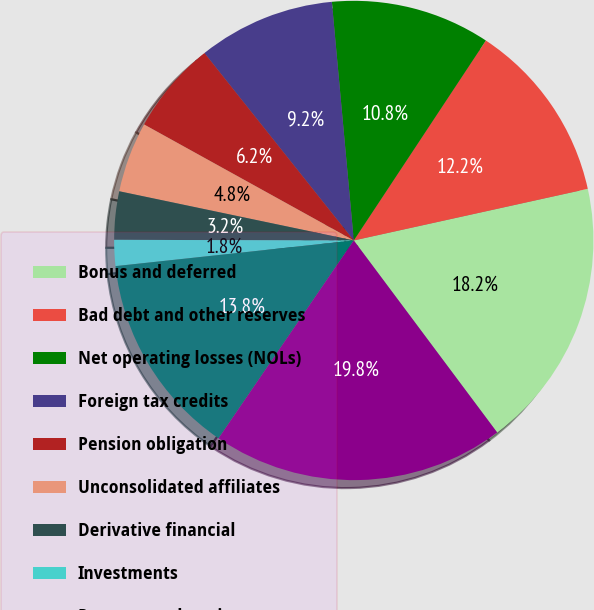Convert chart. <chart><loc_0><loc_0><loc_500><loc_500><pie_chart><fcel>Bonus and deferred<fcel>Bad debt and other reserves<fcel>Net operating losses (NOLs)<fcel>Foreign tax credits<fcel>Pension obligation<fcel>Unconsolidated affiliates<fcel>Derivative financial<fcel>Investments<fcel>Property and equipment<fcel>Capitalized costs and<nl><fcel>18.25%<fcel>12.25%<fcel>10.75%<fcel>9.25%<fcel>6.25%<fcel>4.75%<fcel>3.25%<fcel>1.75%<fcel>13.75%<fcel>19.75%<nl></chart> 